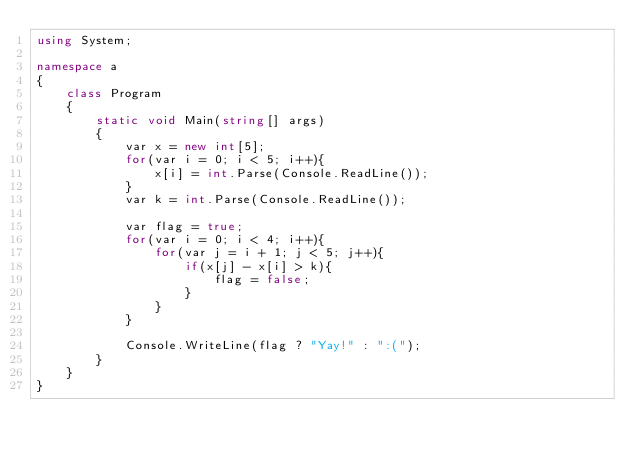<code> <loc_0><loc_0><loc_500><loc_500><_C#_>using System;

namespace a
{
    class Program
    {
        static void Main(string[] args)
        {
            var x = new int[5];
            for(var i = 0; i < 5; i++){
                x[i] = int.Parse(Console.ReadLine());
            }
            var k = int.Parse(Console.ReadLine());

            var flag = true;
            for(var i = 0; i < 4; i++){
                for(var j = i + 1; j < 5; j++){
                    if(x[j] - x[i] > k){
                        flag = false;
                    }
                }
            }

            Console.WriteLine(flag ? "Yay!" : ":(");
        }
    }
}
</code> 